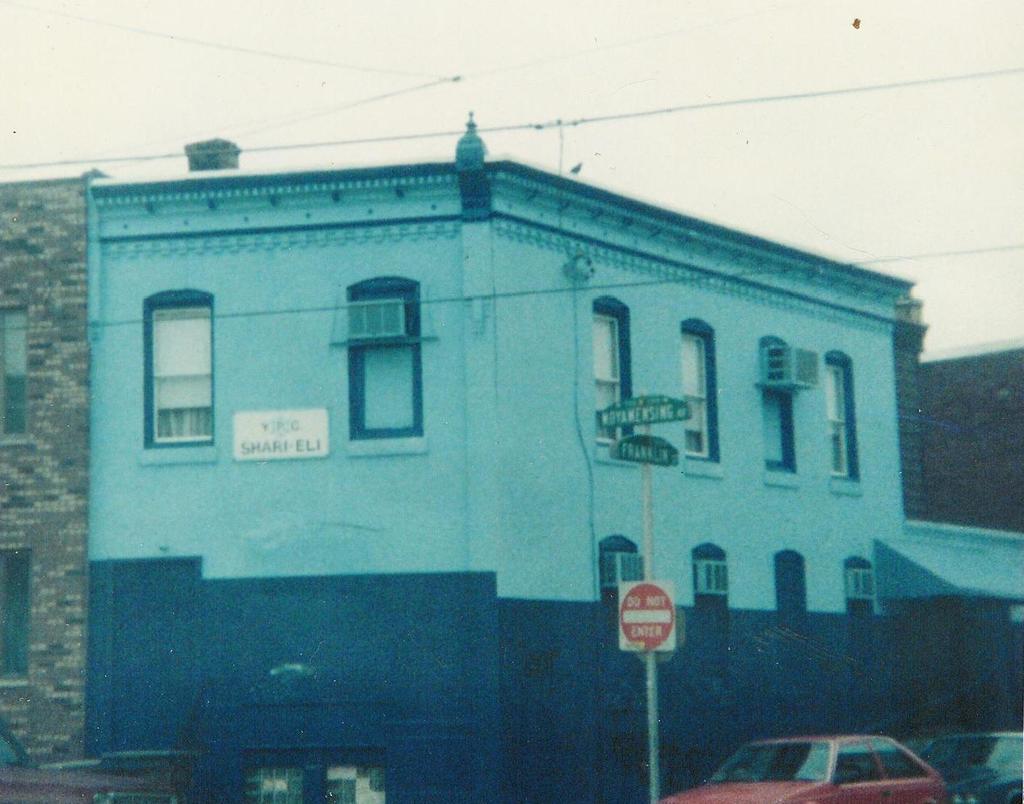What does the red sign say?
Keep it short and to the point. Do not enter. What is the name of the building?
Your response must be concise. Shari eli. 